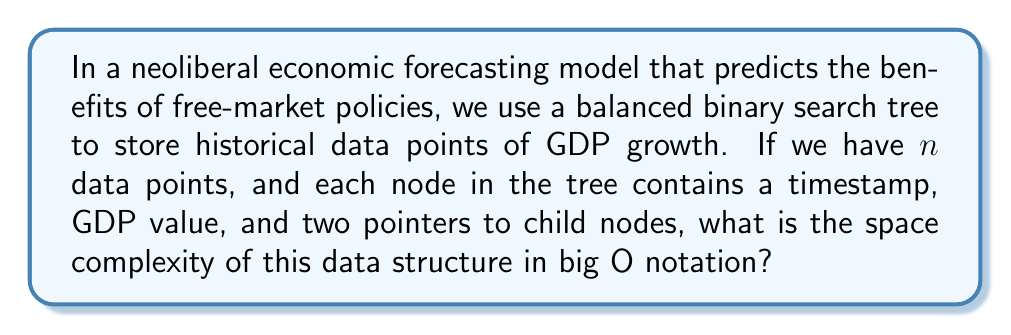Could you help me with this problem? To determine the space complexity, let's break down the components of our balanced binary search tree:

1. Number of nodes: In a balanced binary search tree with $n$ data points, we have exactly $n$ nodes.

2. Space per node:
   - Timestamp: Typically an integer or long, let's assume 8 bytes
   - GDP value: A floating-point number, typically 8 bytes
   - Two pointers: On a 64-bit system, each pointer is 8 bytes, so 16 bytes for both

   Total space per node: $8 + 8 + 16 = 32$ bytes

3. Total space used:
   $$ \text{Total Space} = n \times 32 \text{ bytes} $$

4. Big O notation:
   The space complexity is directly proportional to the number of nodes $n$. The constant factor (32 bytes) is ignored in big O notation.

Therefore, the space complexity of this balanced binary search tree is $O(n)$.

This linear space complexity is efficient for storing and accessing historical economic data, allowing for quick retrieval and updates, which is crucial for making timely policy decisions in a free-market economy.
Answer: $O(n)$ 